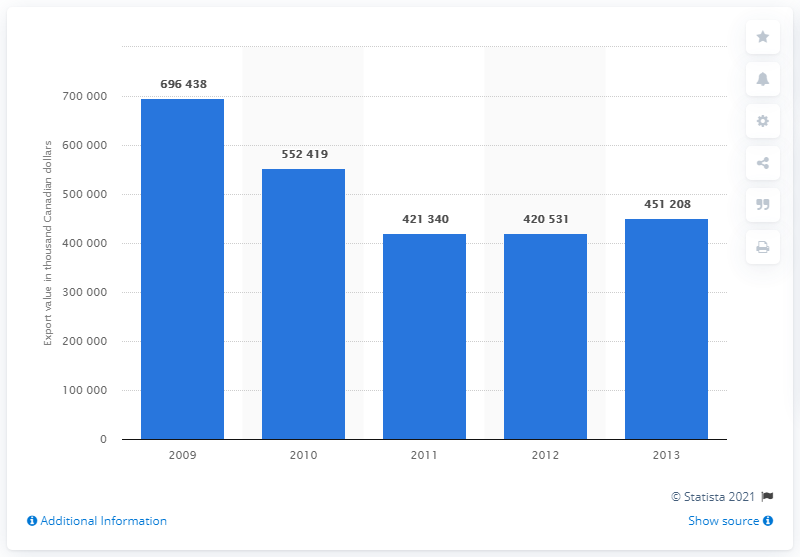Highlight a few significant elements in this photo. Since 2009, the value of maple sugar and maple syrup exported from Austria has decreased. 